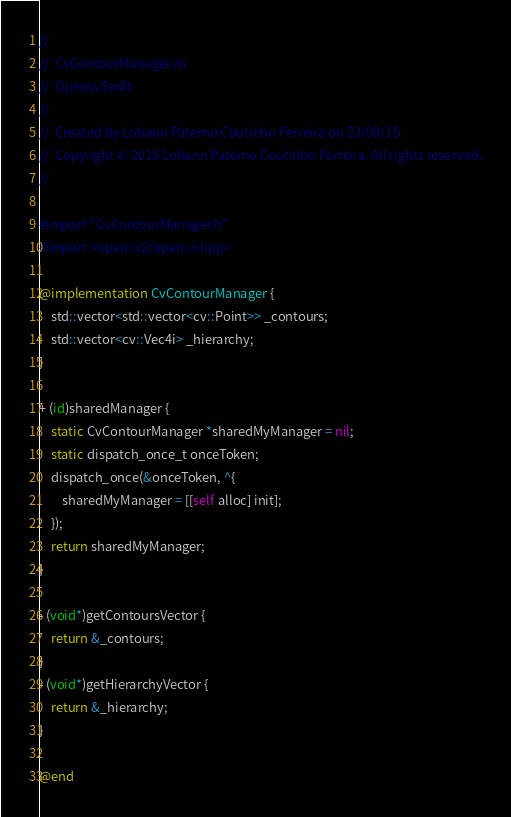Convert code to text. <code><loc_0><loc_0><loc_500><loc_500><_ObjectiveC_>//
//  CvContourManager.m
//  OpencvSwift
//
//  Created by Lohann Paterno Coutinho Ferreira on 23/09/15.
//  Copyright © 2015 Lohann Paterno Coutinho Ferreira. All rights reserved.
//

#import "CvContourManager.h"
#import <opencv2/opencv.hpp>

@implementation CvContourManager {
    std::vector<std::vector<cv::Point>> _contours;
    std::vector<cv::Vec4i> _hierarchy;
}

+ (id)sharedManager {
    static CvContourManager *sharedMyManager = nil;
    static dispatch_once_t onceToken;
    dispatch_once(&onceToken, ^{
        sharedMyManager = [[self alloc] init];
    });
    return sharedMyManager;
}

- (void*)getContoursVector {
    return &_contours;
}
- (void*)getHierarchyVector {
    return &_hierarchy;
}

@end
</code> 